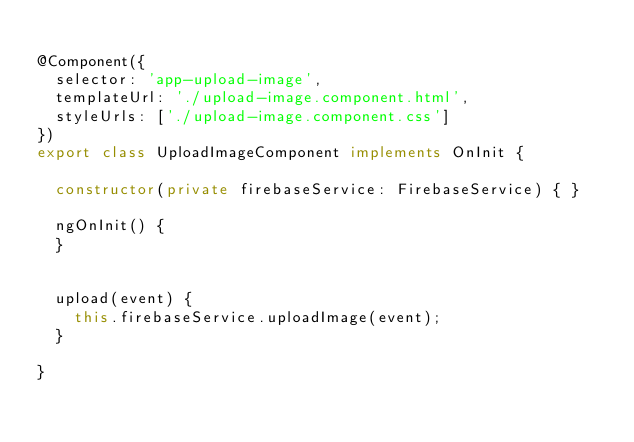<code> <loc_0><loc_0><loc_500><loc_500><_TypeScript_>
@Component({
  selector: 'app-upload-image',
  templateUrl: './upload-image.component.html',
  styleUrls: ['./upload-image.component.css']
})
export class UploadImageComponent implements OnInit {

  constructor(private firebaseService: FirebaseService) { }

  ngOnInit() {
  }

  
	upload(event) {
		this.firebaseService.uploadImage(event);
	}

}
</code> 